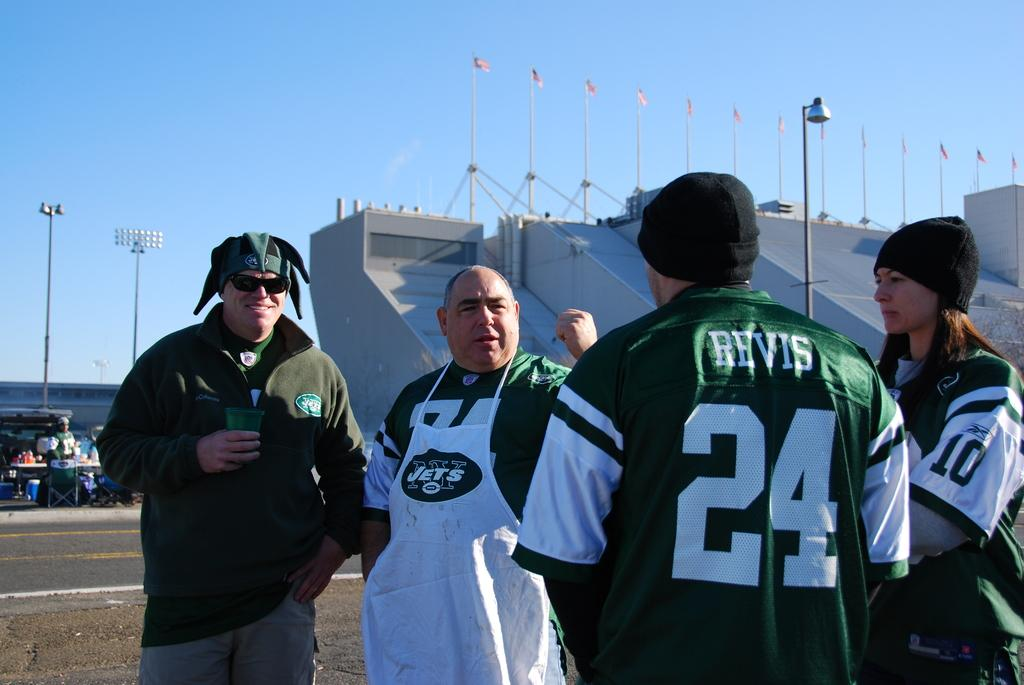<image>
Offer a succinct explanation of the picture presented. a group of jets fans standing in front of the stadium 